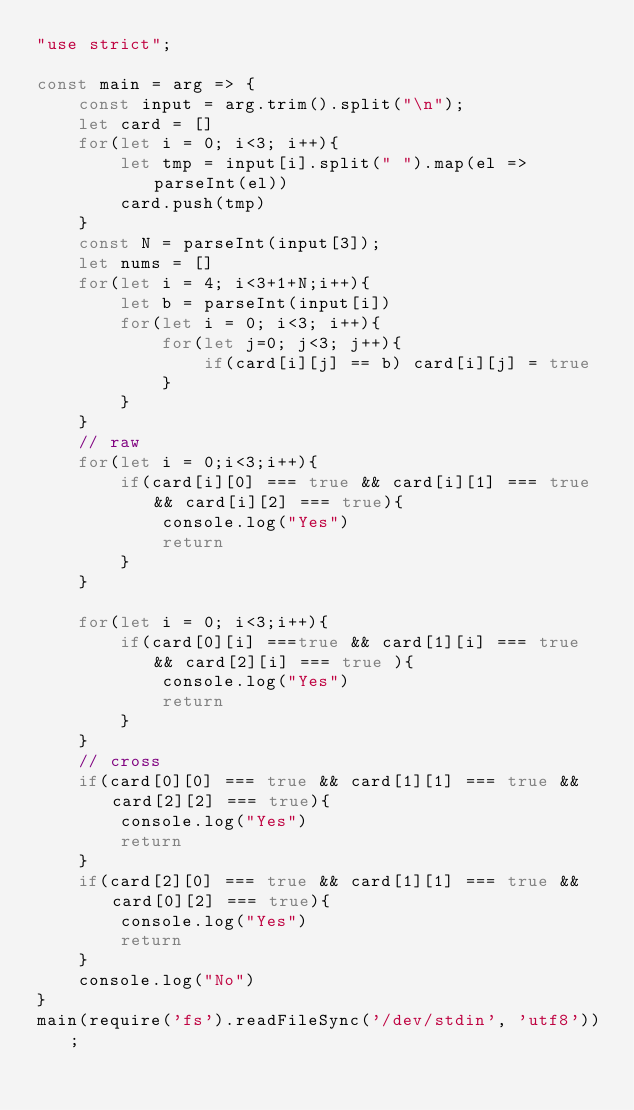<code> <loc_0><loc_0><loc_500><loc_500><_JavaScript_>"use strict";

const main = arg => {
    const input = arg.trim().split("\n");
    let card = []
    for(let i = 0; i<3; i++){
        let tmp = input[i].split(" ").map(el => parseInt(el))
        card.push(tmp)
    }
    const N = parseInt(input[3]);
    let nums = []
    for(let i = 4; i<3+1+N;i++){
        let b = parseInt(input[i])
        for(let i = 0; i<3; i++){
            for(let j=0; j<3; j++){
                if(card[i][j] == b) card[i][j] = true
            }
        }
    }
    // raw
    for(let i = 0;i<3;i++){
        if(card[i][0] === true && card[i][1] === true && card[i][2] === true){
            console.log("Yes")
            return
        }
    }

    for(let i = 0; i<3;i++){
        if(card[0][i] ===true && card[1][i] === true && card[2][i] === true ){
            console.log("Yes")
            return
        }
    }
    // cross
    if(card[0][0] === true && card[1][1] === true && card[2][2] === true){
        console.log("Yes")
        return
    }
    if(card[2][0] === true && card[1][1] === true && card[0][2] === true){
        console.log("Yes")
        return
    }
    console.log("No")
}
main(require('fs').readFileSync('/dev/stdin', 'utf8'));  </code> 